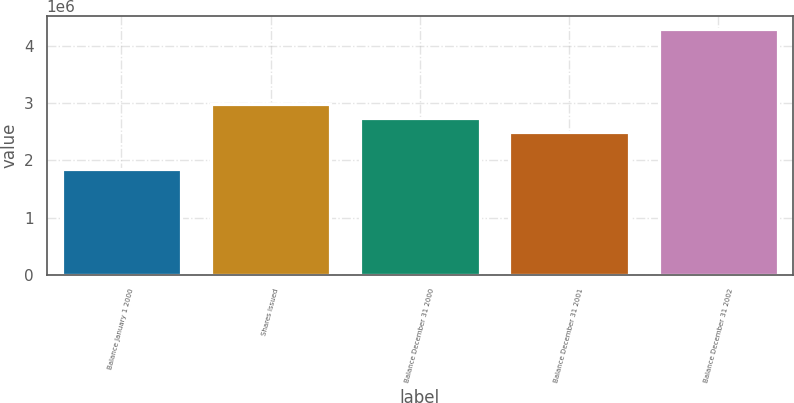Convert chart. <chart><loc_0><loc_0><loc_500><loc_500><bar_chart><fcel>Balance January 1 2000<fcel>Shares issued<fcel>Balance December 31 2000<fcel>Balance December 31 2001<fcel>Balance December 31 2002<nl><fcel>1.84746e+06<fcel>2.99029e+06<fcel>2.74494e+06<fcel>2.4996e+06<fcel>4.30092e+06<nl></chart> 